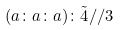<formula> <loc_0><loc_0><loc_500><loc_500>( a \colon a \colon a ) \colon \tilde { 4 } / / 3</formula> 